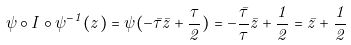Convert formula to latex. <formula><loc_0><loc_0><loc_500><loc_500>\psi \circ I \circ \psi ^ { - 1 } ( z ) = \psi ( - \bar { \tau } \bar { z } + \frac { \tau } { 2 } ) = - \frac { \bar { \tau } } { \tau } \bar { z } + \frac { 1 } { 2 } = \bar { z } + \frac { 1 } { 2 }</formula> 